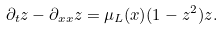Convert formula to latex. <formula><loc_0><loc_0><loc_500><loc_500>\partial _ { t } z - \partial _ { x x } z = \mu _ { L } ( x ) ( 1 - z ^ { 2 } ) z .</formula> 